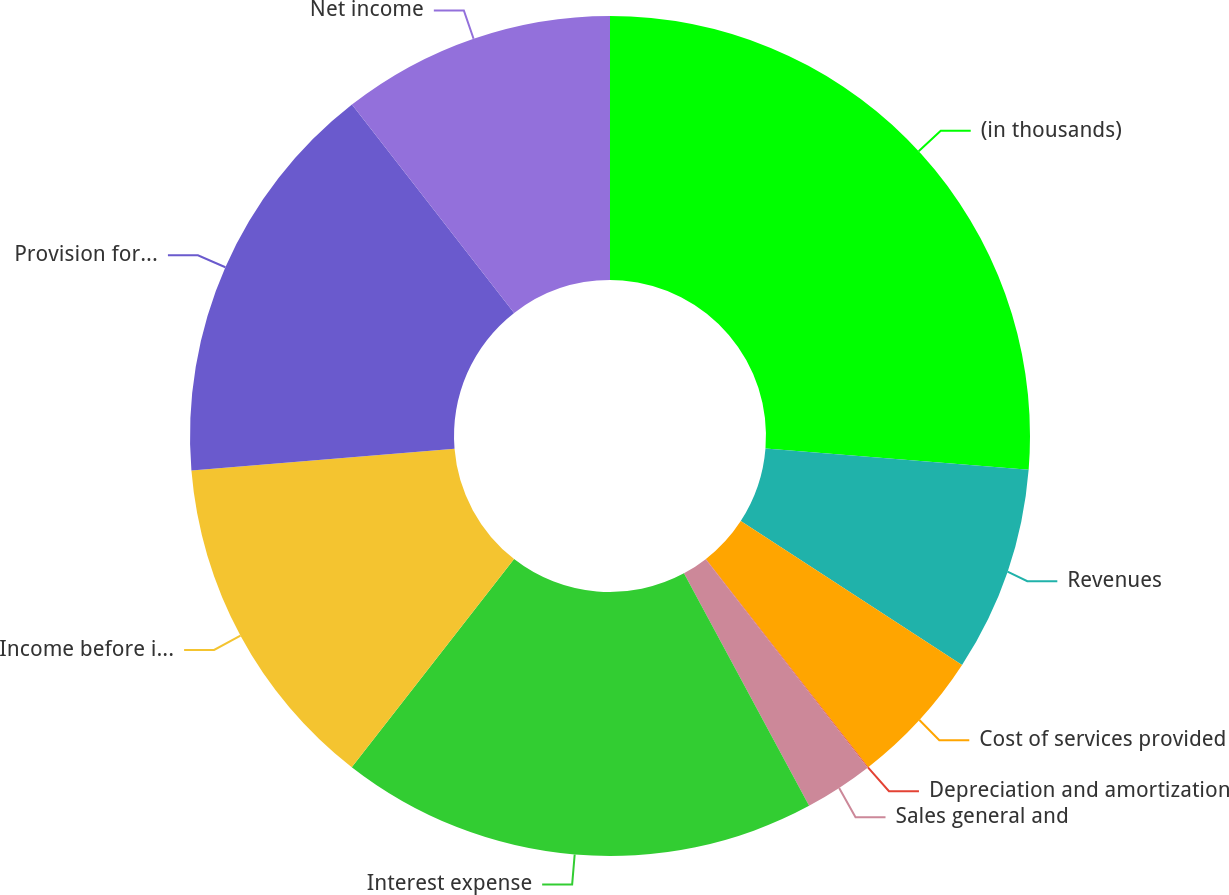Convert chart to OTSL. <chart><loc_0><loc_0><loc_500><loc_500><pie_chart><fcel>(in thousands)<fcel>Revenues<fcel>Cost of services provided<fcel>Depreciation and amortization<fcel>Sales general and<fcel>Interest expense<fcel>Income before income taxes<fcel>Provision for income taxes<fcel>Net income<nl><fcel>26.28%<fcel>7.9%<fcel>5.28%<fcel>0.03%<fcel>2.65%<fcel>18.4%<fcel>13.15%<fcel>15.78%<fcel>10.53%<nl></chart> 